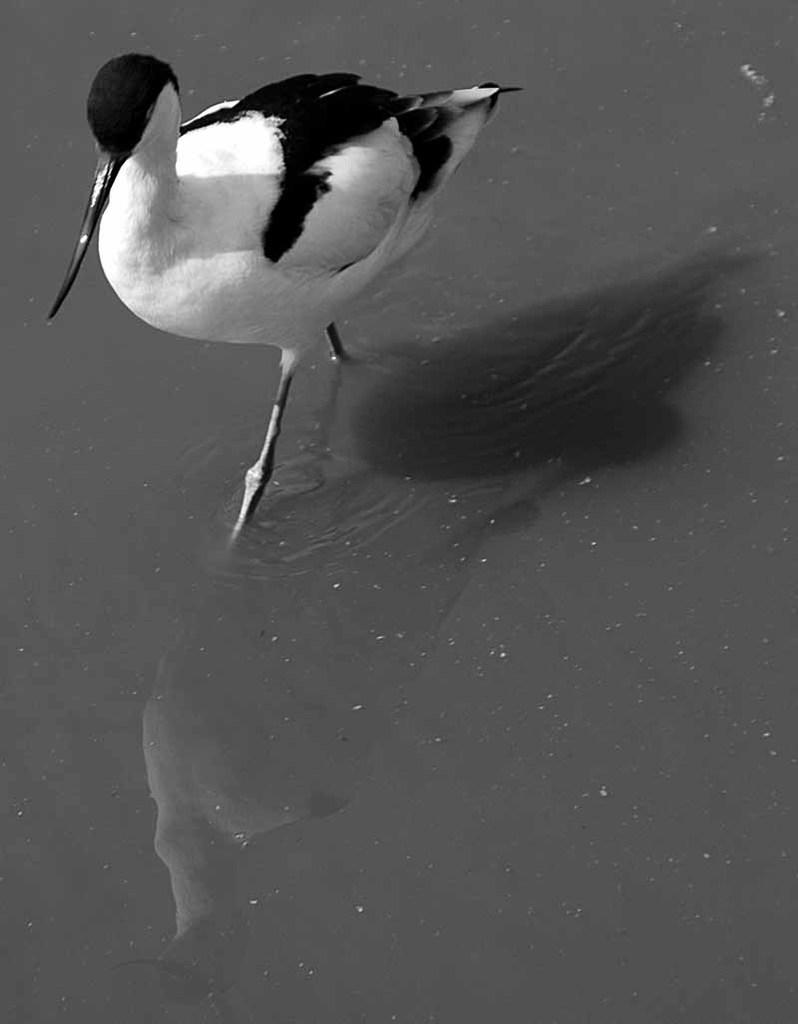What type of animal can be seen in the image? There is a water bird in the image. Where is the water bird located? The water bird is present in the water. What type of boot is the water bird wearing in the image? There is no boot present in the image, as water birds do not wear boots. 